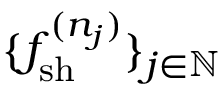Convert formula to latex. <formula><loc_0><loc_0><loc_500><loc_500>\{ f _ { s h } ^ { ( n _ { j } ) } \} _ { j \in \mathbb { N } }</formula> 